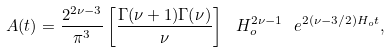<formula> <loc_0><loc_0><loc_500><loc_500>A ( t ) = \frac { 2 ^ { 2 \nu - 3 } } { \pi ^ { 3 } } \left [ \frac { \Gamma ( \nu + 1 ) \Gamma ( \nu ) } { \nu } \right ] \ H ^ { 2 \nu - 1 } _ { o } \ e ^ { 2 ( \nu - 3 / 2 ) H _ { o } t } ,</formula> 